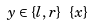Convert formula to latex. <formula><loc_0><loc_0><loc_500><loc_500>y \in \{ l , r \} \ \{ x \}</formula> 